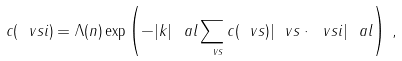<formula> <loc_0><loc_0><loc_500><loc_500>c ( \ v s i ) = \Lambda ( n ) \exp \left ( - | k | ^ { \ } a l \sum _ { \ v s } c ( \ v s ) | \ v s \cdot \ v s i | ^ { \ } a l \right ) \, ,</formula> 